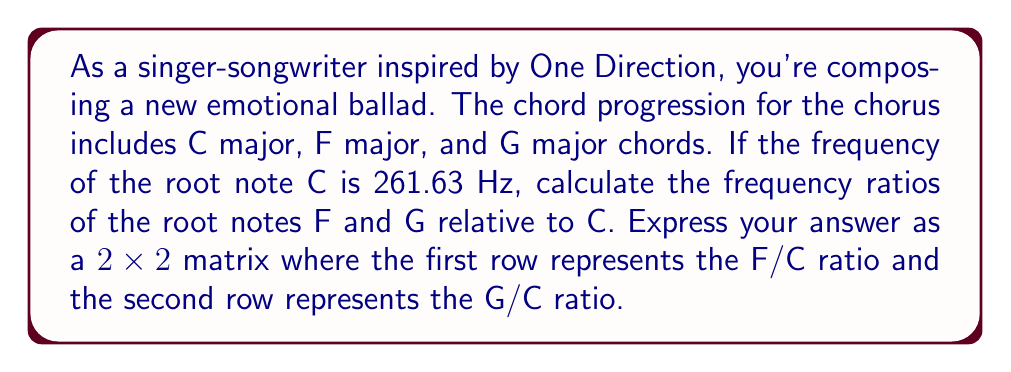Solve this math problem. Let's approach this step-by-step:

1) In Western music, the frequency ratio between two notes an octave apart is 2:1.

2) There are 12 semitones in an octave, and the frequency ratio for each semitone is the 12th root of 2:

   $r = \sqrt[12]{2} \approx 1.05946309$

3) The number of semitones between notes:
   - C to F: 5 semitones
   - C to G: 7 semitones

4) To calculate the frequency ratio for F relative to C:
   $\text{F/C ratio} = r^5 = (1.05946309)^5 \approx 1.3348398$

5) To calculate the frequency ratio for G relative to C:
   $\text{G/C ratio} = r^7 = (1.05946309)^7 \approx 1.4983070$

6) We can represent these ratios in a 2x2 matrix:

   $$\begin{bmatrix}
   \text{F/C} & 0 \\
   0 & \text{G/C}
   \end{bmatrix} = 
   \begin{bmatrix}
   1.3348398 & 0 \\
   0 & 1.4983070
   \end{bmatrix}$$
Answer: $$\begin{bmatrix}
1.3348398 & 0 \\
0 & 1.4983070
\end{bmatrix}$$ 